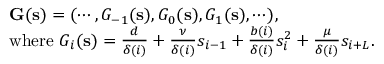Convert formula to latex. <formula><loc_0><loc_0><loc_500><loc_500>\begin{array} { r l } & { G ( s ) = ( \cdots , G _ { - 1 } ( s ) , G _ { 0 } ( s ) , G _ { 1 } ( s ) , \cdots ) , } \\ & { w h e r e G _ { i } ( s ) = \frac { d } { \delta ( i ) } + \frac { \nu } { \delta ( i ) } s _ { i - 1 } + \frac { b ( i ) } { \delta ( i ) } s _ { i } ^ { 2 } + \frac { \mu } { \delta ( i ) } s _ { i + L } . } \end{array}</formula> 